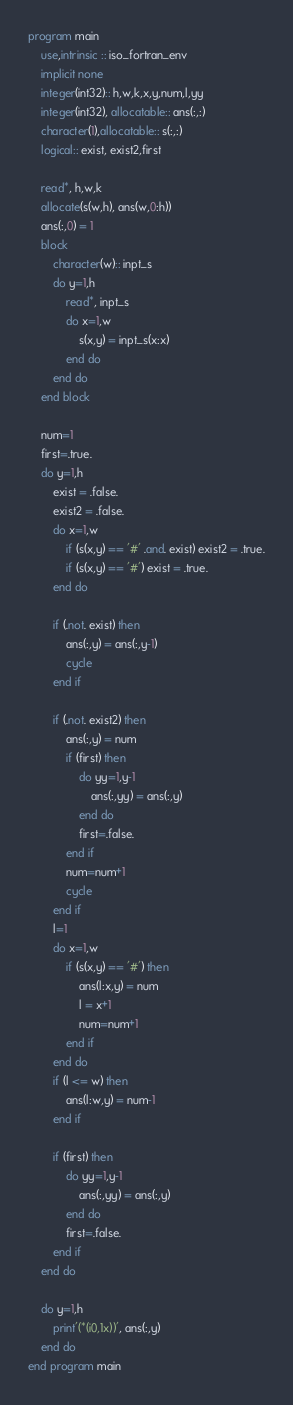Convert code to text. <code><loc_0><loc_0><loc_500><loc_500><_FORTRAN_>program main
    use,intrinsic :: iso_fortran_env
    implicit none
    integer(int32):: h,w,k,x,y,num,l,yy
    integer(int32), allocatable:: ans(:,:)
    character(1),allocatable:: s(:,:)
    logical:: exist, exist2,first

    read*, h,w,k
    allocate(s(w,h), ans(w,0:h))
    ans(:,0) = 1
    block
        character(w):: inpt_s
        do y=1,h
            read*, inpt_s
            do x=1,w
                s(x,y) = inpt_s(x:x)
            end do
        end do
    end block
    
    num=1
    first=.true.
    do y=1,h
        exist = .false.
        exist2 = .false.
        do x=1,w
            if (s(x,y) == '#' .and. exist) exist2 = .true.
            if (s(x,y) == '#') exist = .true.
        end do

        if (.not. exist) then
            ans(:,y) = ans(:,y-1)
            cycle
        end if

        if (.not. exist2) then
            ans(:,y) = num
            if (first) then
                do yy=1,y-1
                    ans(:,yy) = ans(:,y)
                end do
                first=.false. 
            end if
            num=num+1
            cycle
        end if
        l=1
        do x=1,w
            if (s(x,y) == '#') then
                ans(l:x,y) = num
                l = x+1
                num=num+1
            end if
        end do
        if (l <= w) then
            ans(l:w,y) = num-1
        end if
        
        if (first) then
            do yy=1,y-1
                ans(:,yy) = ans(:,y)
            end do
            first=.false. 
        end if
    end do

    do y=1,h
        print'(*(i0,1x))', ans(:,y)
    end do
end program main</code> 